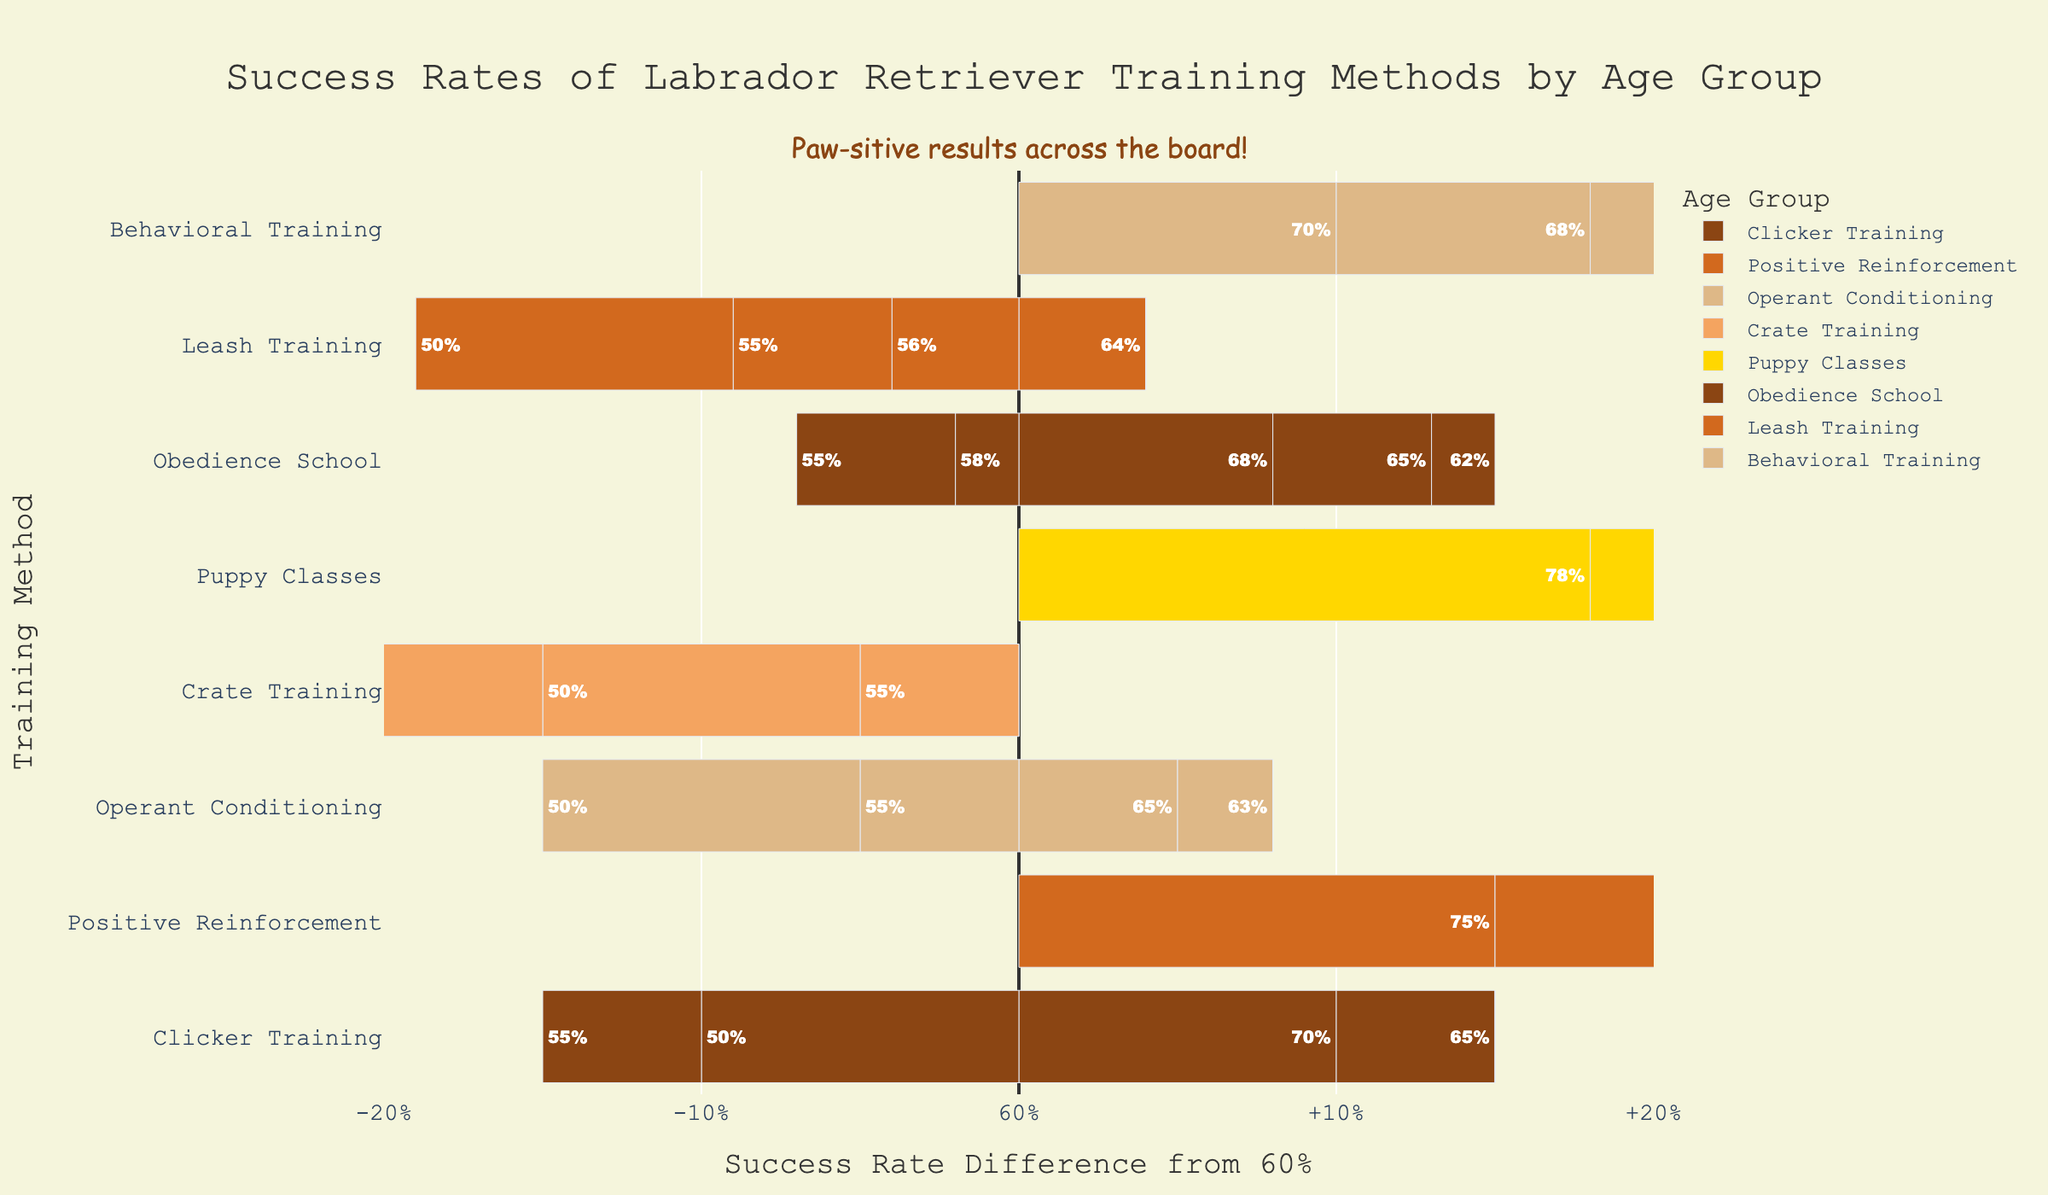What training method shows the highest success rate for Labrador Retrievers aged 6-8 months? To determine the highest success rate for Labrador Retrievers aged 6-8 months, we compare the success rates of all training methods listed under this age group. Puppy Classes has the highest success rate with 70%.
Answer: Puppy Classes What is the difference in success rate between Clicker Training and Obedience School for dogs aged 4-6 months? Comparing the success rates for dogs aged 4-6 months, Clicker Training has 65% success, and Obedience School has 65%. The difference is 65% - 65% = 0%.
Answer: 0% Which training method has the lowest success rate for dogs aged 10-12 months and what is that rate? For dogs aged 10-12 months, the training methods have the following success rates: Clicker Training (55%), Positive Reinforcement (65%), Operant Conditioning (50%), Crate Training (48%), Puppy Classes (60%), Obedience School (55%), Leash Training (50%), and Behavioral Training (60%). Crate Training has the lowest success rate at 48%.
Answer: Crate Training, 48% How does the success rate of Positive Reinforcement change with age? The success rates for Positive Reinforcement across age groups are: 2-4 months (75%), 4-6 months (70%), 6-8 months (65%), 8-10 months (60%), and 10-12 months (65%). It decreases initially from 75% to 60% but then increases slightly to 65%.
Answer: Decreases initially, then increases What is the average success rate for Operant Conditioning across all age groups? The success rates for Operant Conditioning are: 65%, 63%, 60%, 55%, and 50%. The sum is 65 + 63 + 60 + 55 + 50 = 293. Dividing by 5 (total number of age groups) gives an average of 293 / 5 = 58.6%.
Answer: 58.6% Which training method has the smallest range in success rates across different age groups? To find the training method with the smallest range, calculate the difference between the highest and lowest success rates for each method:
Clicker Training (70% - 50% = 20%), Positive Reinforcement (75% - 60% = 15%), Operant Conditioning (65% - 50% = 15%), Crate Training (60% - 48% = 12%), Puppy Classes (78% - 60% = 18%), Obedience School (68% - 55% = 13%), Leash Training (64% - 50% = 14%), Behavioral Training (70% - 60% = 10%). Behavioral Training has the smallest range of 10%.
Answer: Behavioral Training Which age group shows the highest overall success rate across all training methods? Summarize the success rates for each age group across all training methods. Calculate these sums: 
- 2-4 months: 70% + 75% + 65% + 60% + 78% + 68% + 64% + 70% = 550%
- 4-6 months: 65% + 70% + 63% + 55% + 73% + 65% + 60% + 68% = 519%
- 6-8 months: 60% + 65% + 60% + 50% + 70% + 62% + 56% + 65% = 488%
- 8-10 months: 50% + 60% + 55% + 50% + 65% + 58% + 55% + 63% = 456%
- 10-12 months: 55% + 65% + 50% + 48% + 60% + 55% + 50% + 60% = 443%
The age group, 2-4 months, has the highest overall success rate with 550%.
Answer: 2-4 months By how much does Puppy Classes' success rate decline from age 2-4 months to age 10-12 months? The success rate for Puppy Classes at age 2-4 months is 78%, and at age 10-12 months is 60%. The decline is 78% - 60% = 18%.
Answer: 18% Which two training methods have the most similar success rates across age groups? Comparing the success rates of all training methods across age groups, Clicker Training (70%, 65%, 60%, 50%, 55%) and Obedience School (68%, 65%, 62%, 58%, 55%) have the most similar values, only varying slightly by a couple of percentage points across all age groups.
Answer: Clicker Training and Obedience School 